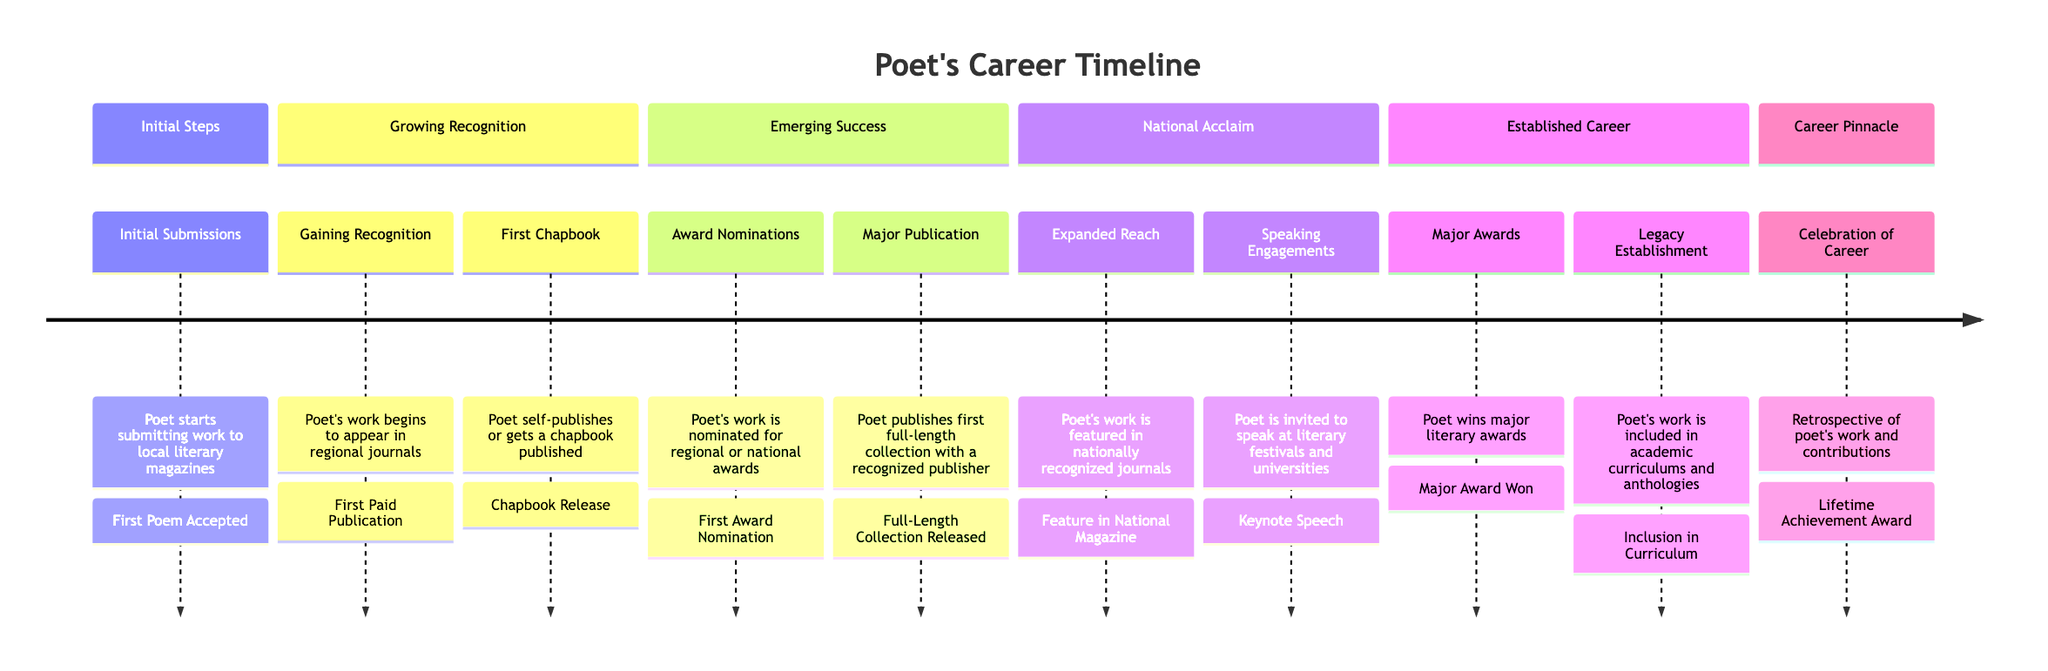What is the first milestone in a poet's career according to the timeline? The timeline indicates that the first milestone is "First Poem Accepted," which occurs during the "Initial Submissions" stage.
Answer: First Poem Accepted How many major stages are represented in the timeline? The timeline is divided into six main stages: Initial Steps, Growing Recognition, Emerging Success, National Acclaim, Established Career, and Career Pinnacle. By counting these sections, we find there are six stages.
Answer: 6 Which milestone corresponds to the "Major Publication" stage? According to the timeline, the milestone for the "Major Publication" stage is "Full-Length Collection Released." This is stated directly in the description of that stage.
Answer: Full-Length Collection Released What is the final milestone listed in the diagram? The last milestone in the timeline is "Lifetime Achievement Award," which is part of the "Career Pinnacle" stage. The placement at the end signifies it's the final achievement in the sequence.
Answer: Lifetime Achievement Award In which stage does the poet receive their first award nomination? The timeline specifies that the first award nomination occurs in the "Award Nominations" stage, which is clearly labeled in the diagram.
Answer: Award Nominations What entities are associated with the "Gaining Recognition" stage? The "Gaining Recognition" stage includes the entities "Regional Poetry Review" and "State Arts Journal." The timeline lists these entities explicitly under the corresponding stage.
Answer: Regional Poetry Review, State Arts Journal Which section includes the "Keynote Speech" milestone? The "Keynote Speech" milestone falls under the "Speaking Engagements" section. This is outlined in the "National Acclaim" stage of the timeline.
Answer: Speaking Engagements What is a major achievement listed in the "Established Career" section? Within the "Established Career" section, the major achievement noted is "Major Award Won." This informs us of the recognition the poet attained in their career.
Answer: Major Award Won 